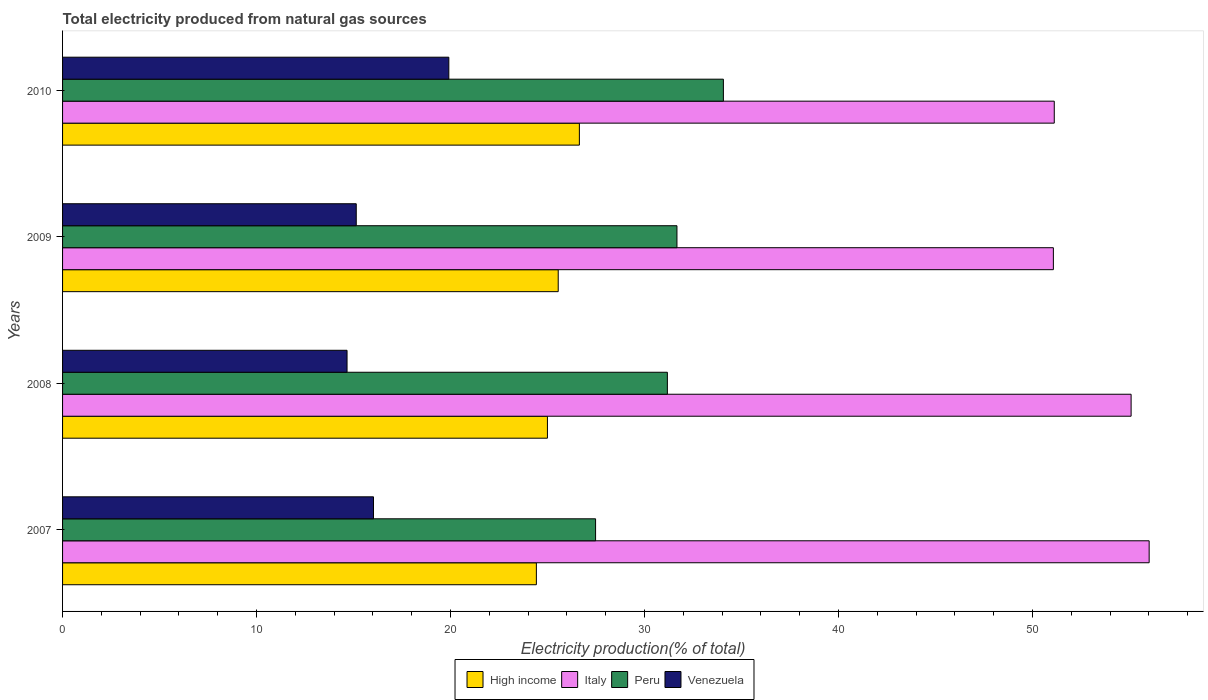How many different coloured bars are there?
Offer a terse response. 4. How many groups of bars are there?
Your answer should be very brief. 4. How many bars are there on the 3rd tick from the top?
Ensure brevity in your answer.  4. How many bars are there on the 1st tick from the bottom?
Keep it short and to the point. 4. What is the label of the 1st group of bars from the top?
Your response must be concise. 2010. What is the total electricity produced in Venezuela in 2008?
Your response must be concise. 14.67. Across all years, what is the maximum total electricity produced in Italy?
Keep it short and to the point. 56.01. Across all years, what is the minimum total electricity produced in Peru?
Offer a very short reply. 27.48. In which year was the total electricity produced in Peru maximum?
Provide a short and direct response. 2010. What is the total total electricity produced in Peru in the graph?
Provide a succinct answer. 124.39. What is the difference between the total electricity produced in High income in 2008 and that in 2010?
Your answer should be very brief. -1.65. What is the difference between the total electricity produced in Peru in 2008 and the total electricity produced in Italy in 2007?
Offer a very short reply. -24.84. What is the average total electricity produced in High income per year?
Give a very brief answer. 25.4. In the year 2010, what is the difference between the total electricity produced in Venezuela and total electricity produced in High income?
Provide a short and direct response. -6.73. In how many years, is the total electricity produced in Venezuela greater than 16 %?
Your answer should be very brief. 2. What is the ratio of the total electricity produced in Italy in 2007 to that in 2009?
Make the answer very short. 1.1. Is the difference between the total electricity produced in Venezuela in 2008 and 2009 greater than the difference between the total electricity produced in High income in 2008 and 2009?
Provide a succinct answer. Yes. What is the difference between the highest and the second highest total electricity produced in Peru?
Your answer should be very brief. 2.39. What is the difference between the highest and the lowest total electricity produced in Venezuela?
Your answer should be compact. 5.25. In how many years, is the total electricity produced in Peru greater than the average total electricity produced in Peru taken over all years?
Provide a succinct answer. 3. Is it the case that in every year, the sum of the total electricity produced in High income and total electricity produced in Venezuela is greater than the sum of total electricity produced in Italy and total electricity produced in Peru?
Your answer should be very brief. No. What does the 4th bar from the top in 2010 represents?
Offer a terse response. High income. What does the 1st bar from the bottom in 2007 represents?
Your response must be concise. High income. Is it the case that in every year, the sum of the total electricity produced in Peru and total electricity produced in High income is greater than the total electricity produced in Italy?
Your answer should be very brief. No. How many bars are there?
Provide a short and direct response. 16. How many years are there in the graph?
Offer a very short reply. 4. Does the graph contain any zero values?
Keep it short and to the point. No. How many legend labels are there?
Your answer should be very brief. 4. How are the legend labels stacked?
Provide a short and direct response. Horizontal. What is the title of the graph?
Your answer should be compact. Total electricity produced from natural gas sources. What is the label or title of the X-axis?
Your answer should be very brief. Electricity production(% of total). What is the Electricity production(% of total) in High income in 2007?
Your answer should be very brief. 24.42. What is the Electricity production(% of total) of Italy in 2007?
Offer a very short reply. 56.01. What is the Electricity production(% of total) in Peru in 2007?
Your answer should be very brief. 27.48. What is the Electricity production(% of total) of Venezuela in 2007?
Make the answer very short. 16.03. What is the Electricity production(% of total) of High income in 2008?
Provide a short and direct response. 25. What is the Electricity production(% of total) of Italy in 2008?
Ensure brevity in your answer.  55.08. What is the Electricity production(% of total) in Peru in 2008?
Make the answer very short. 31.18. What is the Electricity production(% of total) of Venezuela in 2008?
Make the answer very short. 14.67. What is the Electricity production(% of total) of High income in 2009?
Your answer should be compact. 25.55. What is the Electricity production(% of total) in Italy in 2009?
Provide a short and direct response. 51.08. What is the Electricity production(% of total) of Peru in 2009?
Ensure brevity in your answer.  31.67. What is the Electricity production(% of total) of Venezuela in 2009?
Offer a very short reply. 15.14. What is the Electricity production(% of total) in High income in 2010?
Ensure brevity in your answer.  26.64. What is the Electricity production(% of total) of Italy in 2010?
Provide a succinct answer. 51.12. What is the Electricity production(% of total) in Peru in 2010?
Your answer should be very brief. 34.07. What is the Electricity production(% of total) of Venezuela in 2010?
Keep it short and to the point. 19.91. Across all years, what is the maximum Electricity production(% of total) in High income?
Your answer should be very brief. 26.64. Across all years, what is the maximum Electricity production(% of total) of Italy?
Ensure brevity in your answer.  56.01. Across all years, what is the maximum Electricity production(% of total) in Peru?
Your response must be concise. 34.07. Across all years, what is the maximum Electricity production(% of total) in Venezuela?
Your answer should be compact. 19.91. Across all years, what is the minimum Electricity production(% of total) of High income?
Provide a succinct answer. 24.42. Across all years, what is the minimum Electricity production(% of total) of Italy?
Make the answer very short. 51.08. Across all years, what is the minimum Electricity production(% of total) of Peru?
Offer a very short reply. 27.48. Across all years, what is the minimum Electricity production(% of total) in Venezuela?
Your answer should be compact. 14.67. What is the total Electricity production(% of total) of High income in the graph?
Keep it short and to the point. 101.61. What is the total Electricity production(% of total) of Italy in the graph?
Give a very brief answer. 213.29. What is the total Electricity production(% of total) of Peru in the graph?
Provide a short and direct response. 124.39. What is the total Electricity production(% of total) in Venezuela in the graph?
Make the answer very short. 65.74. What is the difference between the Electricity production(% of total) of High income in 2007 and that in 2008?
Ensure brevity in your answer.  -0.57. What is the difference between the Electricity production(% of total) of Italy in 2007 and that in 2008?
Your response must be concise. 0.93. What is the difference between the Electricity production(% of total) in Peru in 2007 and that in 2008?
Your answer should be very brief. -3.7. What is the difference between the Electricity production(% of total) in Venezuela in 2007 and that in 2008?
Offer a very short reply. 1.36. What is the difference between the Electricity production(% of total) of High income in 2007 and that in 2009?
Keep it short and to the point. -1.13. What is the difference between the Electricity production(% of total) of Italy in 2007 and that in 2009?
Ensure brevity in your answer.  4.94. What is the difference between the Electricity production(% of total) of Peru in 2007 and that in 2009?
Provide a short and direct response. -4.19. What is the difference between the Electricity production(% of total) of Venezuela in 2007 and that in 2009?
Offer a terse response. 0.89. What is the difference between the Electricity production(% of total) of High income in 2007 and that in 2010?
Ensure brevity in your answer.  -2.22. What is the difference between the Electricity production(% of total) in Italy in 2007 and that in 2010?
Provide a succinct answer. 4.89. What is the difference between the Electricity production(% of total) of Peru in 2007 and that in 2010?
Provide a succinct answer. -6.59. What is the difference between the Electricity production(% of total) in Venezuela in 2007 and that in 2010?
Your answer should be very brief. -3.88. What is the difference between the Electricity production(% of total) of High income in 2008 and that in 2009?
Keep it short and to the point. -0.56. What is the difference between the Electricity production(% of total) in Italy in 2008 and that in 2009?
Make the answer very short. 4.01. What is the difference between the Electricity production(% of total) of Peru in 2008 and that in 2009?
Provide a short and direct response. -0.49. What is the difference between the Electricity production(% of total) in Venezuela in 2008 and that in 2009?
Provide a short and direct response. -0.47. What is the difference between the Electricity production(% of total) of High income in 2008 and that in 2010?
Your answer should be compact. -1.65. What is the difference between the Electricity production(% of total) in Italy in 2008 and that in 2010?
Ensure brevity in your answer.  3.96. What is the difference between the Electricity production(% of total) in Peru in 2008 and that in 2010?
Offer a terse response. -2.89. What is the difference between the Electricity production(% of total) in Venezuela in 2008 and that in 2010?
Offer a very short reply. -5.25. What is the difference between the Electricity production(% of total) in High income in 2009 and that in 2010?
Provide a succinct answer. -1.09. What is the difference between the Electricity production(% of total) of Italy in 2009 and that in 2010?
Ensure brevity in your answer.  -0.05. What is the difference between the Electricity production(% of total) of Peru in 2009 and that in 2010?
Ensure brevity in your answer.  -2.39. What is the difference between the Electricity production(% of total) of Venezuela in 2009 and that in 2010?
Make the answer very short. -4.77. What is the difference between the Electricity production(% of total) in High income in 2007 and the Electricity production(% of total) in Italy in 2008?
Offer a very short reply. -30.66. What is the difference between the Electricity production(% of total) of High income in 2007 and the Electricity production(% of total) of Peru in 2008?
Keep it short and to the point. -6.75. What is the difference between the Electricity production(% of total) in High income in 2007 and the Electricity production(% of total) in Venezuela in 2008?
Make the answer very short. 9.76. What is the difference between the Electricity production(% of total) in Italy in 2007 and the Electricity production(% of total) in Peru in 2008?
Make the answer very short. 24.84. What is the difference between the Electricity production(% of total) in Italy in 2007 and the Electricity production(% of total) in Venezuela in 2008?
Make the answer very short. 41.35. What is the difference between the Electricity production(% of total) in Peru in 2007 and the Electricity production(% of total) in Venezuela in 2008?
Ensure brevity in your answer.  12.81. What is the difference between the Electricity production(% of total) of High income in 2007 and the Electricity production(% of total) of Italy in 2009?
Offer a very short reply. -26.65. What is the difference between the Electricity production(% of total) in High income in 2007 and the Electricity production(% of total) in Peru in 2009?
Your response must be concise. -7.25. What is the difference between the Electricity production(% of total) in High income in 2007 and the Electricity production(% of total) in Venezuela in 2009?
Provide a short and direct response. 9.29. What is the difference between the Electricity production(% of total) of Italy in 2007 and the Electricity production(% of total) of Peru in 2009?
Provide a succinct answer. 24.34. What is the difference between the Electricity production(% of total) in Italy in 2007 and the Electricity production(% of total) in Venezuela in 2009?
Your answer should be compact. 40.87. What is the difference between the Electricity production(% of total) in Peru in 2007 and the Electricity production(% of total) in Venezuela in 2009?
Keep it short and to the point. 12.34. What is the difference between the Electricity production(% of total) of High income in 2007 and the Electricity production(% of total) of Italy in 2010?
Give a very brief answer. -26.7. What is the difference between the Electricity production(% of total) of High income in 2007 and the Electricity production(% of total) of Peru in 2010?
Provide a succinct answer. -9.64. What is the difference between the Electricity production(% of total) in High income in 2007 and the Electricity production(% of total) in Venezuela in 2010?
Provide a short and direct response. 4.51. What is the difference between the Electricity production(% of total) of Italy in 2007 and the Electricity production(% of total) of Peru in 2010?
Give a very brief answer. 21.95. What is the difference between the Electricity production(% of total) in Italy in 2007 and the Electricity production(% of total) in Venezuela in 2010?
Your response must be concise. 36.1. What is the difference between the Electricity production(% of total) in Peru in 2007 and the Electricity production(% of total) in Venezuela in 2010?
Ensure brevity in your answer.  7.57. What is the difference between the Electricity production(% of total) in High income in 2008 and the Electricity production(% of total) in Italy in 2009?
Keep it short and to the point. -26.08. What is the difference between the Electricity production(% of total) of High income in 2008 and the Electricity production(% of total) of Peru in 2009?
Provide a succinct answer. -6.68. What is the difference between the Electricity production(% of total) in High income in 2008 and the Electricity production(% of total) in Venezuela in 2009?
Give a very brief answer. 9.86. What is the difference between the Electricity production(% of total) in Italy in 2008 and the Electricity production(% of total) in Peru in 2009?
Keep it short and to the point. 23.41. What is the difference between the Electricity production(% of total) of Italy in 2008 and the Electricity production(% of total) of Venezuela in 2009?
Offer a very short reply. 39.94. What is the difference between the Electricity production(% of total) in Peru in 2008 and the Electricity production(% of total) in Venezuela in 2009?
Ensure brevity in your answer.  16.04. What is the difference between the Electricity production(% of total) of High income in 2008 and the Electricity production(% of total) of Italy in 2010?
Your response must be concise. -26.13. What is the difference between the Electricity production(% of total) in High income in 2008 and the Electricity production(% of total) in Peru in 2010?
Offer a very short reply. -9.07. What is the difference between the Electricity production(% of total) of High income in 2008 and the Electricity production(% of total) of Venezuela in 2010?
Your response must be concise. 5.08. What is the difference between the Electricity production(% of total) in Italy in 2008 and the Electricity production(% of total) in Peru in 2010?
Provide a short and direct response. 21.02. What is the difference between the Electricity production(% of total) of Italy in 2008 and the Electricity production(% of total) of Venezuela in 2010?
Ensure brevity in your answer.  35.17. What is the difference between the Electricity production(% of total) of Peru in 2008 and the Electricity production(% of total) of Venezuela in 2010?
Provide a short and direct response. 11.27. What is the difference between the Electricity production(% of total) of High income in 2009 and the Electricity production(% of total) of Italy in 2010?
Your response must be concise. -25.57. What is the difference between the Electricity production(% of total) of High income in 2009 and the Electricity production(% of total) of Peru in 2010?
Provide a short and direct response. -8.51. What is the difference between the Electricity production(% of total) in High income in 2009 and the Electricity production(% of total) in Venezuela in 2010?
Make the answer very short. 5.64. What is the difference between the Electricity production(% of total) of Italy in 2009 and the Electricity production(% of total) of Peru in 2010?
Offer a terse response. 17.01. What is the difference between the Electricity production(% of total) of Italy in 2009 and the Electricity production(% of total) of Venezuela in 2010?
Offer a very short reply. 31.16. What is the difference between the Electricity production(% of total) in Peru in 2009 and the Electricity production(% of total) in Venezuela in 2010?
Your answer should be compact. 11.76. What is the average Electricity production(% of total) in High income per year?
Your answer should be compact. 25.4. What is the average Electricity production(% of total) of Italy per year?
Offer a terse response. 53.32. What is the average Electricity production(% of total) in Peru per year?
Ensure brevity in your answer.  31.1. What is the average Electricity production(% of total) in Venezuela per year?
Your answer should be very brief. 16.44. In the year 2007, what is the difference between the Electricity production(% of total) in High income and Electricity production(% of total) in Italy?
Provide a short and direct response. -31.59. In the year 2007, what is the difference between the Electricity production(% of total) in High income and Electricity production(% of total) in Peru?
Your answer should be very brief. -3.05. In the year 2007, what is the difference between the Electricity production(% of total) of High income and Electricity production(% of total) of Venezuela?
Provide a short and direct response. 8.4. In the year 2007, what is the difference between the Electricity production(% of total) in Italy and Electricity production(% of total) in Peru?
Your answer should be very brief. 28.54. In the year 2007, what is the difference between the Electricity production(% of total) in Italy and Electricity production(% of total) in Venezuela?
Your answer should be very brief. 39.98. In the year 2007, what is the difference between the Electricity production(% of total) in Peru and Electricity production(% of total) in Venezuela?
Provide a short and direct response. 11.45. In the year 2008, what is the difference between the Electricity production(% of total) in High income and Electricity production(% of total) in Italy?
Offer a terse response. -30.09. In the year 2008, what is the difference between the Electricity production(% of total) in High income and Electricity production(% of total) in Peru?
Provide a short and direct response. -6.18. In the year 2008, what is the difference between the Electricity production(% of total) of High income and Electricity production(% of total) of Venezuela?
Keep it short and to the point. 10.33. In the year 2008, what is the difference between the Electricity production(% of total) of Italy and Electricity production(% of total) of Peru?
Ensure brevity in your answer.  23.9. In the year 2008, what is the difference between the Electricity production(% of total) in Italy and Electricity production(% of total) in Venezuela?
Provide a succinct answer. 40.42. In the year 2008, what is the difference between the Electricity production(% of total) of Peru and Electricity production(% of total) of Venezuela?
Ensure brevity in your answer.  16.51. In the year 2009, what is the difference between the Electricity production(% of total) in High income and Electricity production(% of total) in Italy?
Your answer should be very brief. -25.53. In the year 2009, what is the difference between the Electricity production(% of total) in High income and Electricity production(% of total) in Peru?
Your response must be concise. -6.12. In the year 2009, what is the difference between the Electricity production(% of total) in High income and Electricity production(% of total) in Venezuela?
Offer a terse response. 10.41. In the year 2009, what is the difference between the Electricity production(% of total) in Italy and Electricity production(% of total) in Peru?
Give a very brief answer. 19.4. In the year 2009, what is the difference between the Electricity production(% of total) in Italy and Electricity production(% of total) in Venezuela?
Keep it short and to the point. 35.94. In the year 2009, what is the difference between the Electricity production(% of total) in Peru and Electricity production(% of total) in Venezuela?
Ensure brevity in your answer.  16.53. In the year 2010, what is the difference between the Electricity production(% of total) in High income and Electricity production(% of total) in Italy?
Offer a very short reply. -24.48. In the year 2010, what is the difference between the Electricity production(% of total) of High income and Electricity production(% of total) of Peru?
Make the answer very short. -7.42. In the year 2010, what is the difference between the Electricity production(% of total) in High income and Electricity production(% of total) in Venezuela?
Keep it short and to the point. 6.73. In the year 2010, what is the difference between the Electricity production(% of total) in Italy and Electricity production(% of total) in Peru?
Ensure brevity in your answer.  17.06. In the year 2010, what is the difference between the Electricity production(% of total) in Italy and Electricity production(% of total) in Venezuela?
Your answer should be very brief. 31.21. In the year 2010, what is the difference between the Electricity production(% of total) in Peru and Electricity production(% of total) in Venezuela?
Provide a succinct answer. 14.15. What is the ratio of the Electricity production(% of total) in High income in 2007 to that in 2008?
Make the answer very short. 0.98. What is the ratio of the Electricity production(% of total) of Italy in 2007 to that in 2008?
Offer a very short reply. 1.02. What is the ratio of the Electricity production(% of total) of Peru in 2007 to that in 2008?
Keep it short and to the point. 0.88. What is the ratio of the Electricity production(% of total) of Venezuela in 2007 to that in 2008?
Keep it short and to the point. 1.09. What is the ratio of the Electricity production(% of total) in High income in 2007 to that in 2009?
Offer a very short reply. 0.96. What is the ratio of the Electricity production(% of total) in Italy in 2007 to that in 2009?
Make the answer very short. 1.1. What is the ratio of the Electricity production(% of total) of Peru in 2007 to that in 2009?
Your answer should be compact. 0.87. What is the ratio of the Electricity production(% of total) in Venezuela in 2007 to that in 2009?
Offer a terse response. 1.06. What is the ratio of the Electricity production(% of total) of High income in 2007 to that in 2010?
Provide a short and direct response. 0.92. What is the ratio of the Electricity production(% of total) of Italy in 2007 to that in 2010?
Your answer should be compact. 1.1. What is the ratio of the Electricity production(% of total) of Peru in 2007 to that in 2010?
Keep it short and to the point. 0.81. What is the ratio of the Electricity production(% of total) of Venezuela in 2007 to that in 2010?
Keep it short and to the point. 0.81. What is the ratio of the Electricity production(% of total) in High income in 2008 to that in 2009?
Your answer should be very brief. 0.98. What is the ratio of the Electricity production(% of total) of Italy in 2008 to that in 2009?
Your answer should be very brief. 1.08. What is the ratio of the Electricity production(% of total) in Peru in 2008 to that in 2009?
Your answer should be compact. 0.98. What is the ratio of the Electricity production(% of total) in Venezuela in 2008 to that in 2009?
Ensure brevity in your answer.  0.97. What is the ratio of the Electricity production(% of total) in High income in 2008 to that in 2010?
Offer a terse response. 0.94. What is the ratio of the Electricity production(% of total) in Italy in 2008 to that in 2010?
Your answer should be compact. 1.08. What is the ratio of the Electricity production(% of total) in Peru in 2008 to that in 2010?
Give a very brief answer. 0.92. What is the ratio of the Electricity production(% of total) in Venezuela in 2008 to that in 2010?
Provide a short and direct response. 0.74. What is the ratio of the Electricity production(% of total) in High income in 2009 to that in 2010?
Make the answer very short. 0.96. What is the ratio of the Electricity production(% of total) of Italy in 2009 to that in 2010?
Offer a very short reply. 1. What is the ratio of the Electricity production(% of total) in Peru in 2009 to that in 2010?
Provide a short and direct response. 0.93. What is the ratio of the Electricity production(% of total) in Venezuela in 2009 to that in 2010?
Your response must be concise. 0.76. What is the difference between the highest and the second highest Electricity production(% of total) of High income?
Provide a short and direct response. 1.09. What is the difference between the highest and the second highest Electricity production(% of total) in Italy?
Give a very brief answer. 0.93. What is the difference between the highest and the second highest Electricity production(% of total) of Peru?
Your answer should be compact. 2.39. What is the difference between the highest and the second highest Electricity production(% of total) in Venezuela?
Provide a short and direct response. 3.88. What is the difference between the highest and the lowest Electricity production(% of total) in High income?
Your response must be concise. 2.22. What is the difference between the highest and the lowest Electricity production(% of total) of Italy?
Your answer should be very brief. 4.94. What is the difference between the highest and the lowest Electricity production(% of total) in Peru?
Your response must be concise. 6.59. What is the difference between the highest and the lowest Electricity production(% of total) of Venezuela?
Make the answer very short. 5.25. 